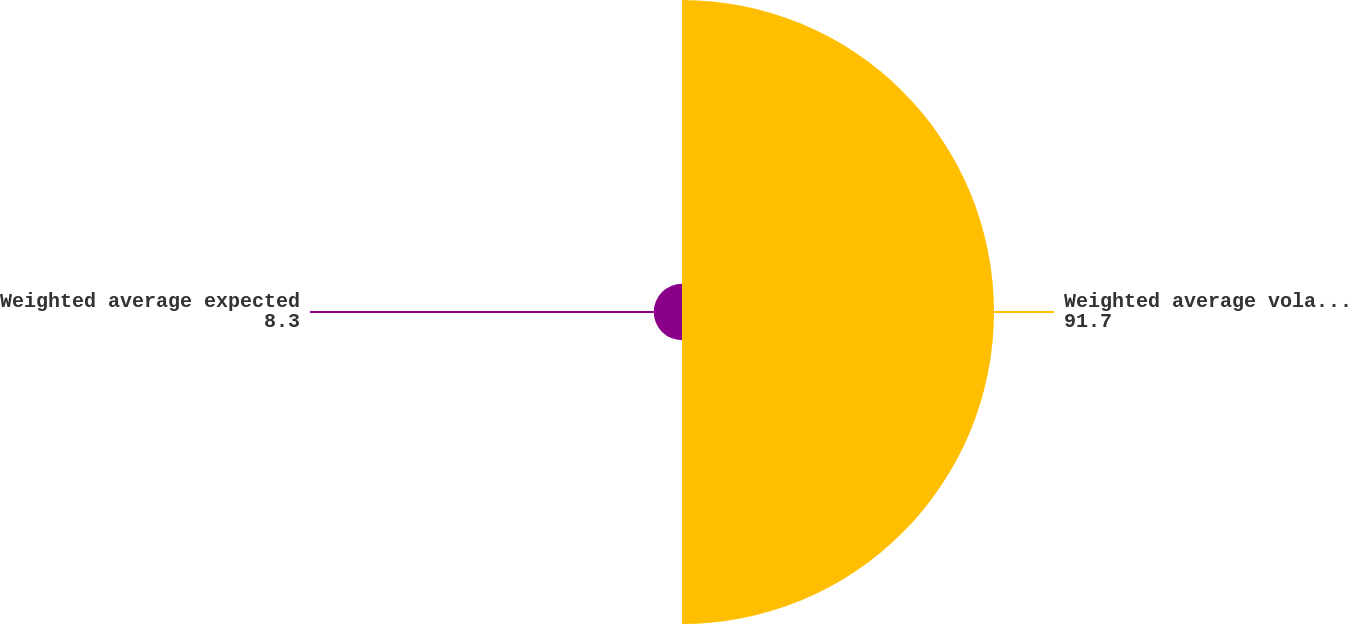Convert chart. <chart><loc_0><loc_0><loc_500><loc_500><pie_chart><fcel>Weighted average volatility<fcel>Weighted average expected<nl><fcel>91.7%<fcel>8.3%<nl></chart> 